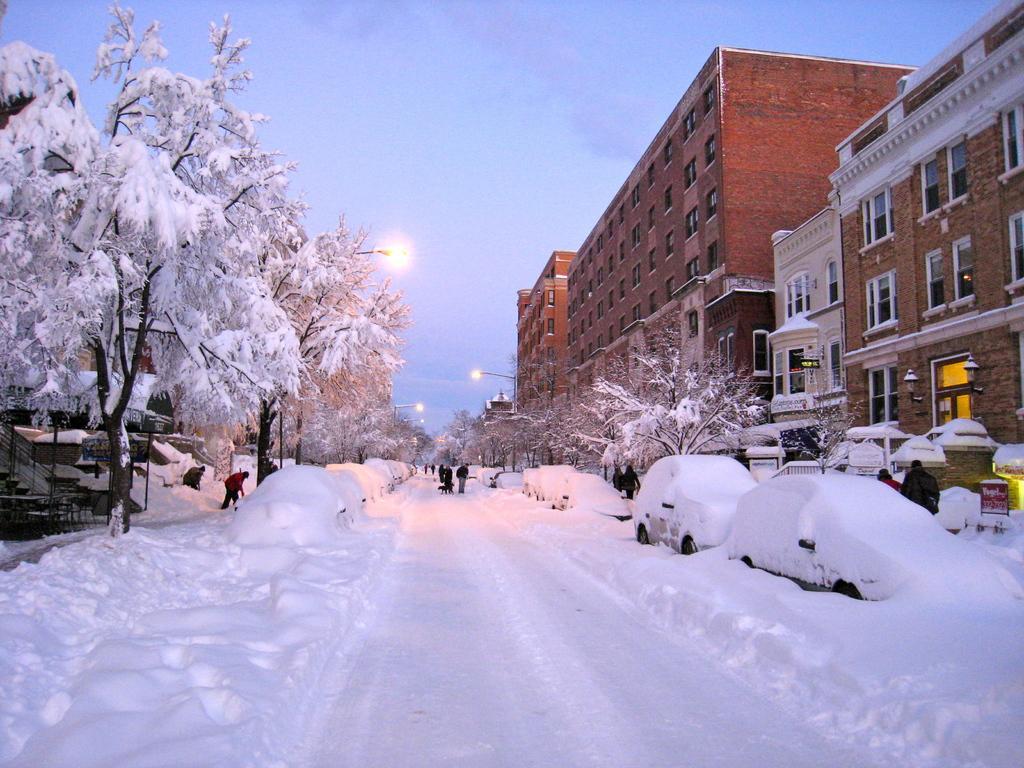Can you describe this image briefly? In the picture I can see the snowfall where we can see roads, trees and vehicles are covered with snow. Here we can see people walking on the road, I can see buildings, light poles and the dark sky in the background. 